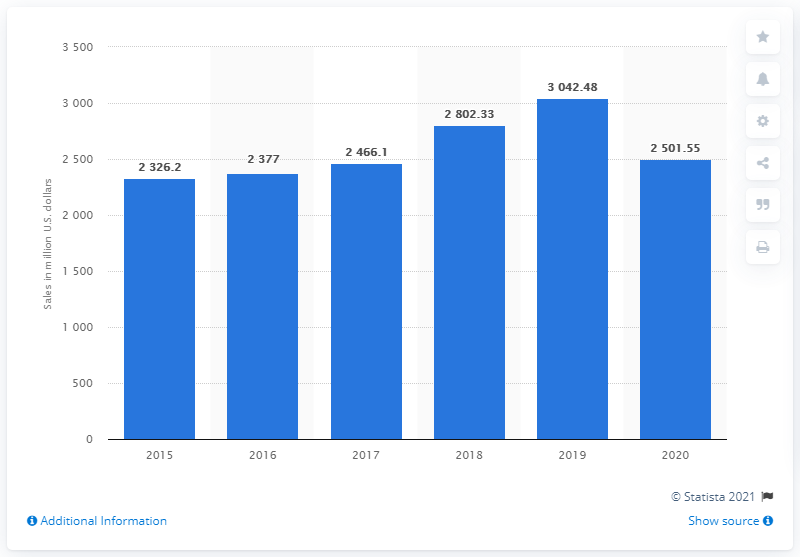Mention a couple of crucial points in this snapshot. In 2020, the total sales of Columbia Sportswear Company were 2501.55. 